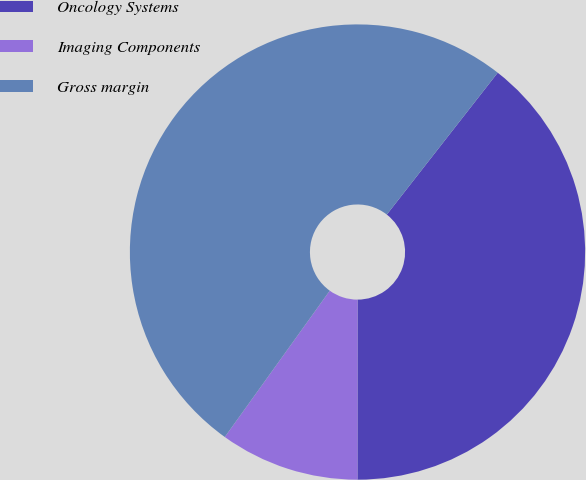Convert chart. <chart><loc_0><loc_0><loc_500><loc_500><pie_chart><fcel>Oncology Systems<fcel>Imaging Components<fcel>Gross margin<nl><fcel>39.45%<fcel>9.9%<fcel>50.66%<nl></chart> 